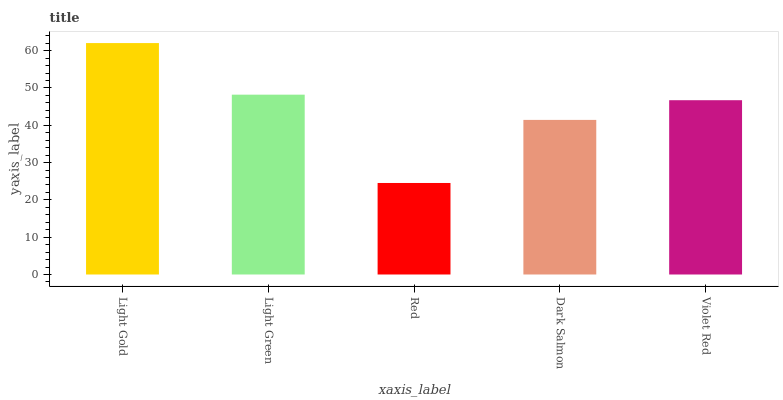Is Red the minimum?
Answer yes or no. Yes. Is Light Gold the maximum?
Answer yes or no. Yes. Is Light Green the minimum?
Answer yes or no. No. Is Light Green the maximum?
Answer yes or no. No. Is Light Gold greater than Light Green?
Answer yes or no. Yes. Is Light Green less than Light Gold?
Answer yes or no. Yes. Is Light Green greater than Light Gold?
Answer yes or no. No. Is Light Gold less than Light Green?
Answer yes or no. No. Is Violet Red the high median?
Answer yes or no. Yes. Is Violet Red the low median?
Answer yes or no. Yes. Is Dark Salmon the high median?
Answer yes or no. No. Is Light Green the low median?
Answer yes or no. No. 